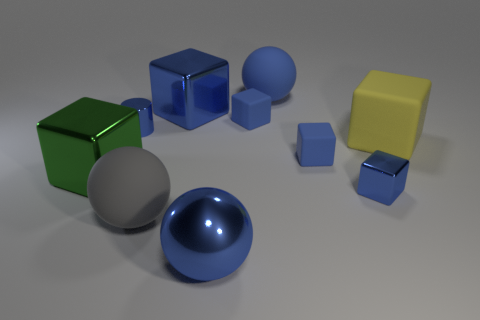What is the shape of the large matte object that is the same color as the shiny ball?
Your answer should be compact. Sphere. What material is the large yellow block?
Your answer should be compact. Rubber. Does the yellow object have the same material as the gray ball?
Offer a very short reply. Yes. What number of matte things are either large blue spheres or small blue cylinders?
Make the answer very short. 1. What shape is the tiny object on the left side of the gray rubber ball?
Your answer should be very brief. Cylinder. There is a gray thing that is the same material as the yellow thing; what is its size?
Provide a succinct answer. Large. The big metallic thing that is both right of the blue cylinder and in front of the yellow thing has what shape?
Make the answer very short. Sphere. Is the color of the large thing in front of the big gray matte ball the same as the small shiny cube?
Your response must be concise. Yes. There is a big blue metal thing behind the large green cube; is it the same shape as the blue metallic thing that is to the right of the blue rubber sphere?
Your response must be concise. Yes. What is the size of the blue ball in front of the big blue shiny block?
Provide a short and direct response. Large. 